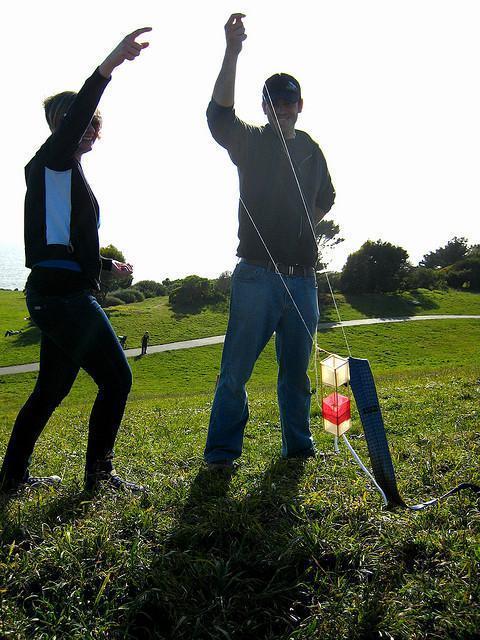How many people are in the photo?
Give a very brief answer. 2. How many donuts are glazed?
Give a very brief answer. 0. 